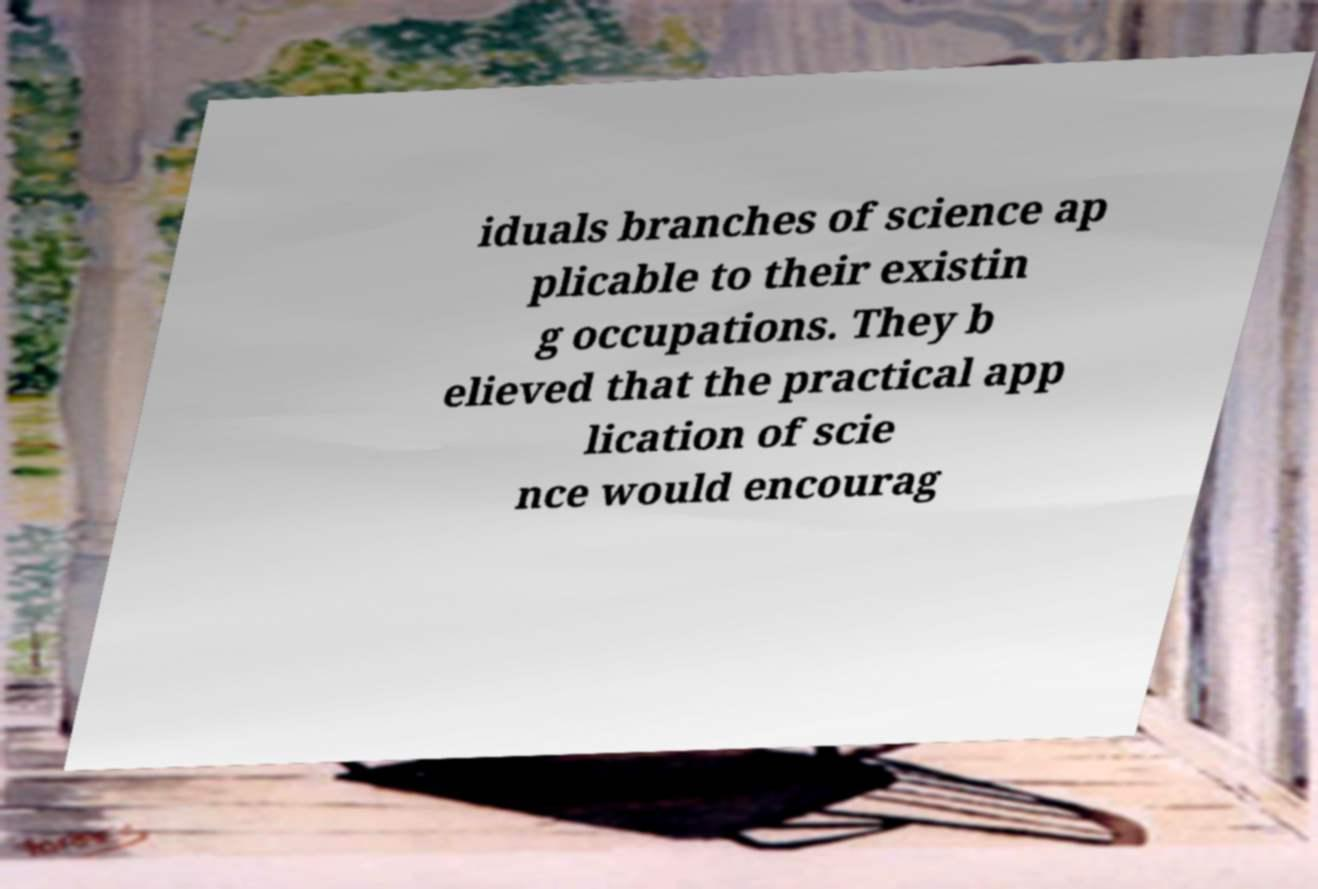What messages or text are displayed in this image? I need them in a readable, typed format. iduals branches of science ap plicable to their existin g occupations. They b elieved that the practical app lication of scie nce would encourag 